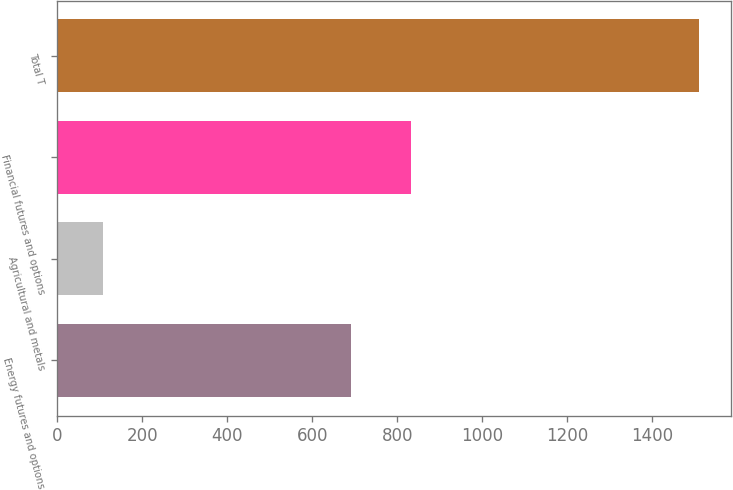Convert chart. <chart><loc_0><loc_0><loc_500><loc_500><bar_chart><fcel>Energy futures and options<fcel>Agricultural and metals<fcel>Financial futures and options<fcel>Total T<nl><fcel>692<fcel>107<fcel>832.2<fcel>1509<nl></chart> 